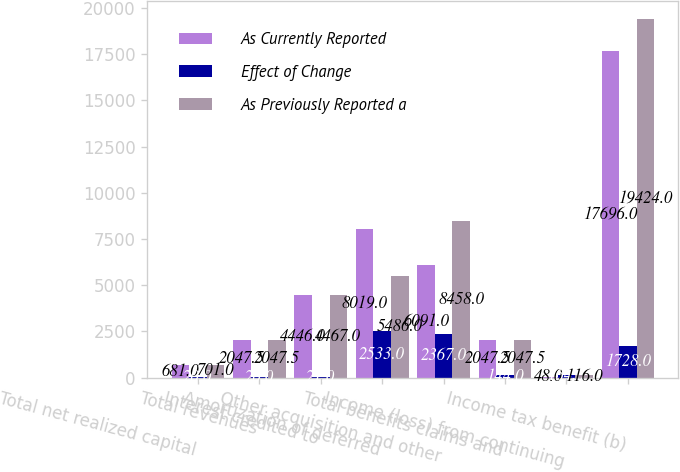<chart> <loc_0><loc_0><loc_500><loc_500><stacked_bar_chart><ecel><fcel>Total net realized capital<fcel>Total revenues<fcel>Interest credited to<fcel>Amortization of deferred<fcel>Other acquisition and other<fcel>Total benefits claims and<fcel>Income (loss) from continuing<fcel>Income tax benefit (b)<nl><fcel>As Currently Reported<fcel>681<fcel>2047.5<fcel>4446<fcel>8019<fcel>6091<fcel>2047.5<fcel>48<fcel>17696<nl><fcel>Effect of Change<fcel>20<fcel>20<fcel>21<fcel>2533<fcel>2367<fcel>144<fcel>164<fcel>1728<nl><fcel>As Previously Reported a<fcel>701<fcel>2047.5<fcel>4467<fcel>5486<fcel>8458<fcel>2047.5<fcel>116<fcel>19424<nl></chart> 